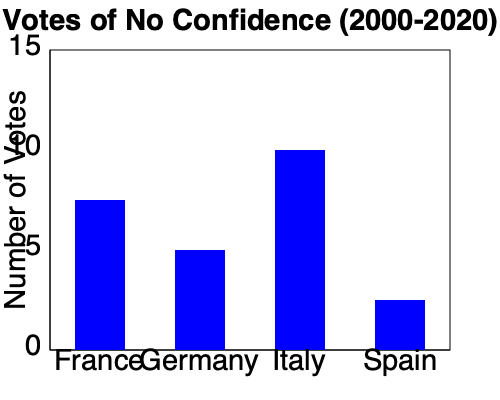Based on the bar graph showing the frequency of votes of no confidence in four European countries between 2000 and 2020, which country has experienced the highest number of such votes, and how does this reflect on the stability of its parliamentary system compared to the others? To answer this question, we need to analyze the bar graph and interpret its implications:

1. Identify the countries: The graph shows data for France, Germany, Italy, and Spain.

2. Compare the heights of the bars:
   - France: approximately 7-8 votes
   - Germany: approximately 5 votes
   - Italy: approximately 10 votes
   - Spain: approximately 2-3 votes

3. Determine the country with the highest number:
   Italy has the tallest bar, indicating the highest number of votes of no confidence (about 10) during the period.

4. Interpret the implications for parliamentary stability:
   - More frequent votes of no confidence generally indicate less stability in the parliamentary system.
   - Italy's high number suggests a more volatile political environment compared to the other countries.
   - Spain, with the lowest number, appears to have the most stable system among the four.
   - France and Germany fall in between, with moderate levels of parliamentary challenges.

5. Consider contextual factors:
   - Constitutional differences: Some countries may have lower thresholds or different procedures for initiating votes of no confidence.
   - Political culture: Frequency of votes may reflect different political norms and expectations in each country.
   - Coalition dynamics: Countries with more fragmented party systems or frequent coalition governments might see more votes of no confidence.

In conclusion, Italy's high frequency of votes of no confidence suggests a less stable parliamentary system compared to the other countries, particularly Spain, which shows the most stability in this regard.
Answer: Italy; indicates less stable parliamentary system 